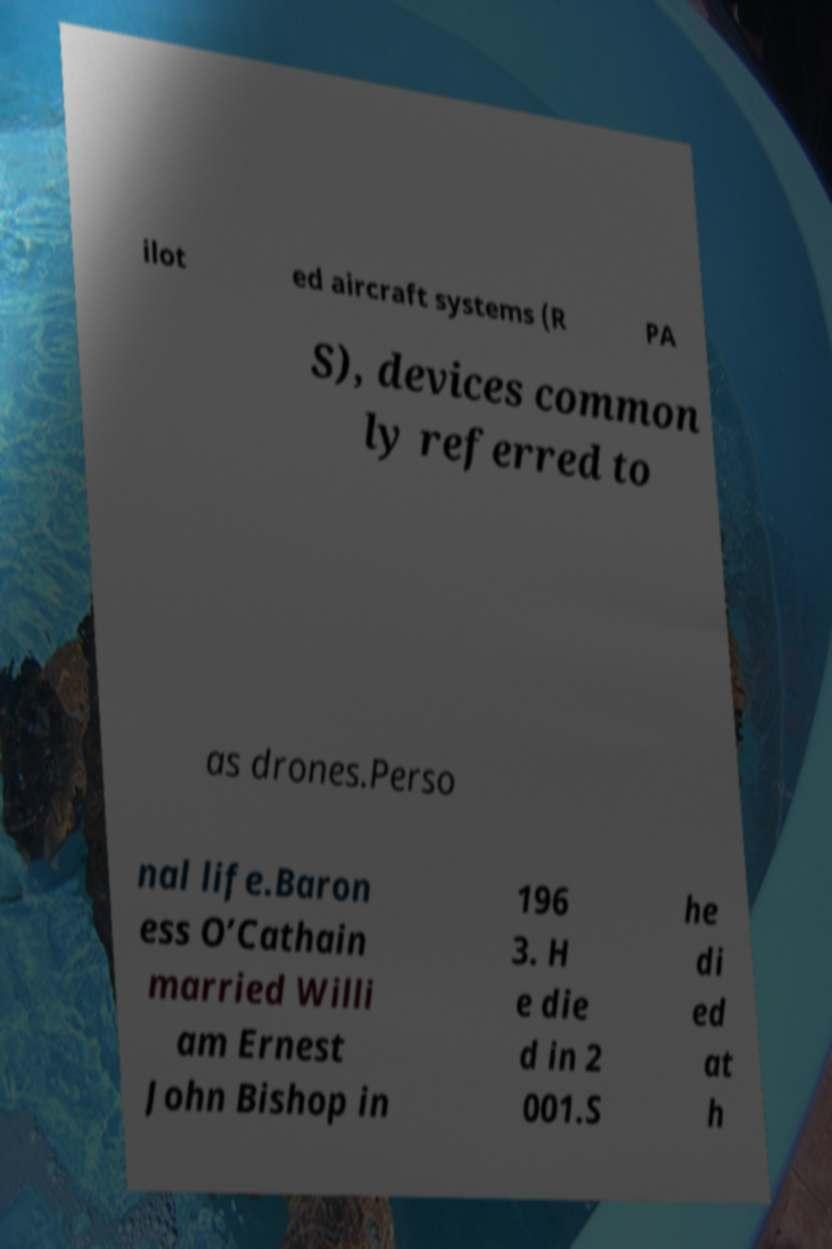I need the written content from this picture converted into text. Can you do that? ilot ed aircraft systems (R PA S), devices common ly referred to as drones.Perso nal life.Baron ess O’Cathain married Willi am Ernest John Bishop in 196 3. H e die d in 2 001.S he di ed at h 